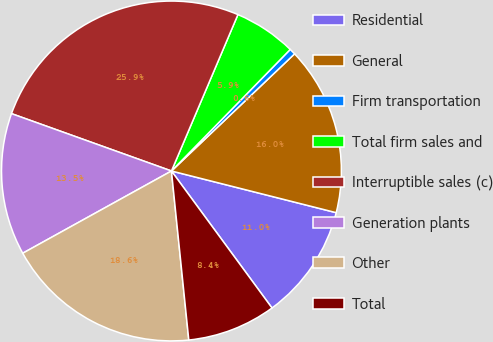<chart> <loc_0><loc_0><loc_500><loc_500><pie_chart><fcel>Residential<fcel>General<fcel>Firm transportation<fcel>Total firm sales and<fcel>Interruptible sales (c)<fcel>Generation plants<fcel>Other<fcel>Total<nl><fcel>10.98%<fcel>16.05%<fcel>0.58%<fcel>5.92%<fcel>25.92%<fcel>13.52%<fcel>18.59%<fcel>8.45%<nl></chart> 